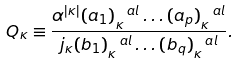Convert formula to latex. <formula><loc_0><loc_0><loc_500><loc_500>Q _ { \kappa } \equiv \frac { \alpha ^ { | \kappa | } ( a _ { 1 } ) _ { \kappa } ^ { \ a l } \dots ( a _ { p } ) _ { \kappa } ^ { \ a l } } { j _ { \kappa } ( b _ { 1 } ) _ { \kappa } ^ { \ a l } \dots ( b _ { q } ) _ { \kappa } ^ { \ a l } } .</formula> 